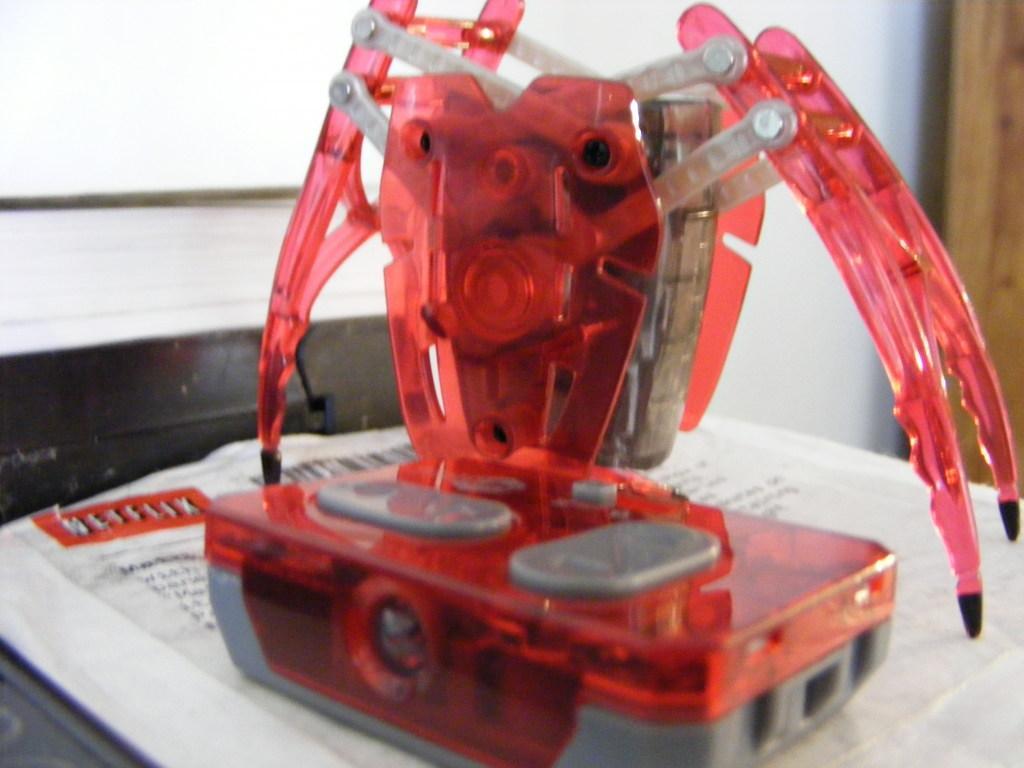How would you summarize this image in a sentence or two? In the picture we can see a desk on it, we can see some papers with some information and on it we can see a remote controller, which is red in color with buttons and beside it, we can see electronic crab which is red in color with legs and in the background we can see a wall with a part of a wooden door. 